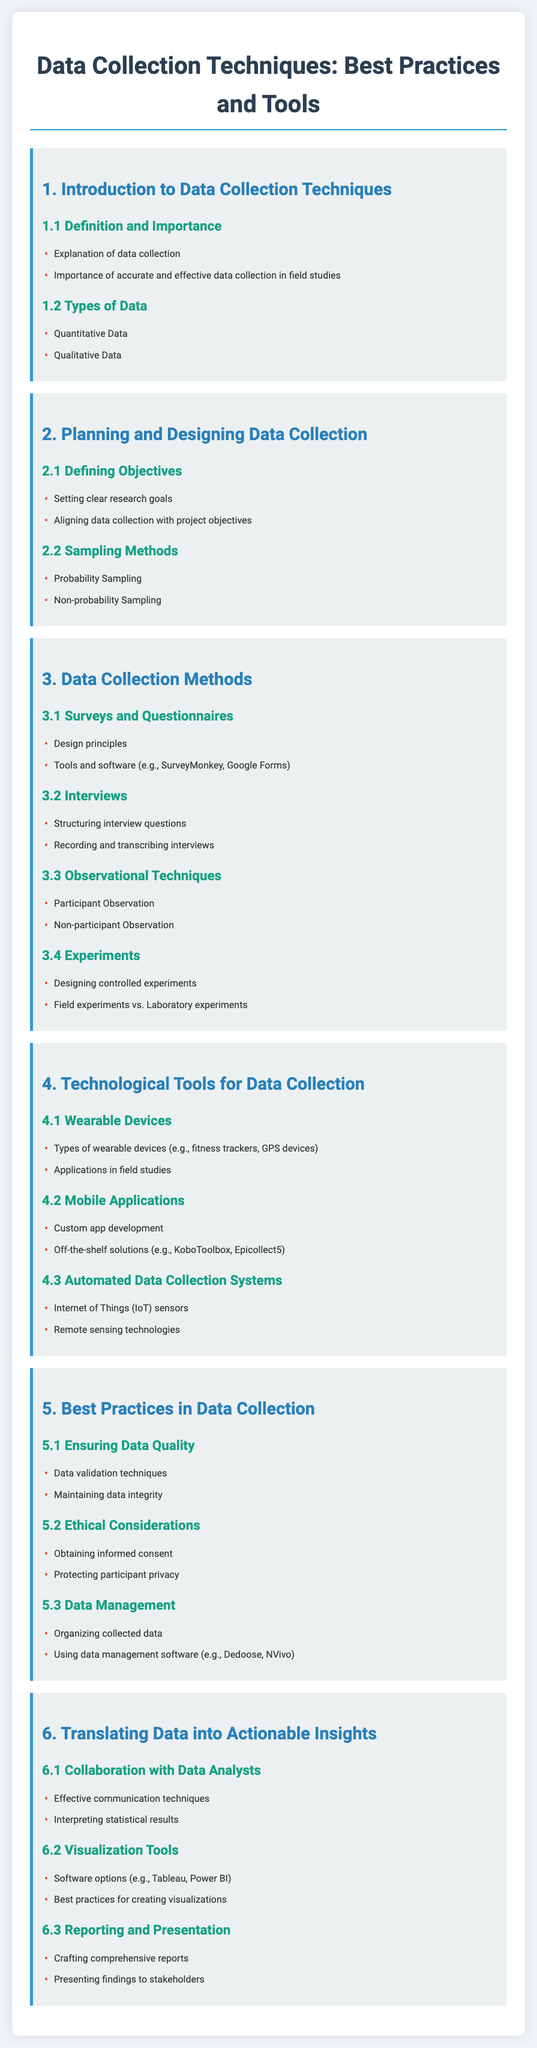what is the title of the document? The title is displayed prominently at the top of the document and indicates the subject matter being discussed.
Answer: Data Collection Techniques: Best Practices and Tools what are the two types of data mentioned? The document outlines different categories of data, which are specified in a section on data types.
Answer: Quantitative Data, Qualitative Data which section covers ethical considerations? The section on ethical considerations can be located under best practices in data collection.
Answer: 5.2 Ethical Considerations how many main sections are there in the document? The document includes a numbered list of main sections, which provides a quick overview of the content structure.
Answer: 6 what is a technological tool mentioned in the document for data collection? The document lists various technological tools categorized under their specific sections aimed at enhancing data collection efforts.
Answer: Wearable Devices what is the focus of section 6? Section 6 is dedicated to describing the methods of converting data into useful insights and collaborative practices with data analysts.
Answer: Translating Data into Actionable Insights what software options are mentioned for visualization tools? The document includes a sub-section that discusses various software tools available for data visualization purposes.
Answer: Tableau, Power BI name one sampling method mentioned in the document. The document specifies different sampling methods applicable in research and data collection.
Answer: Probability Sampling 